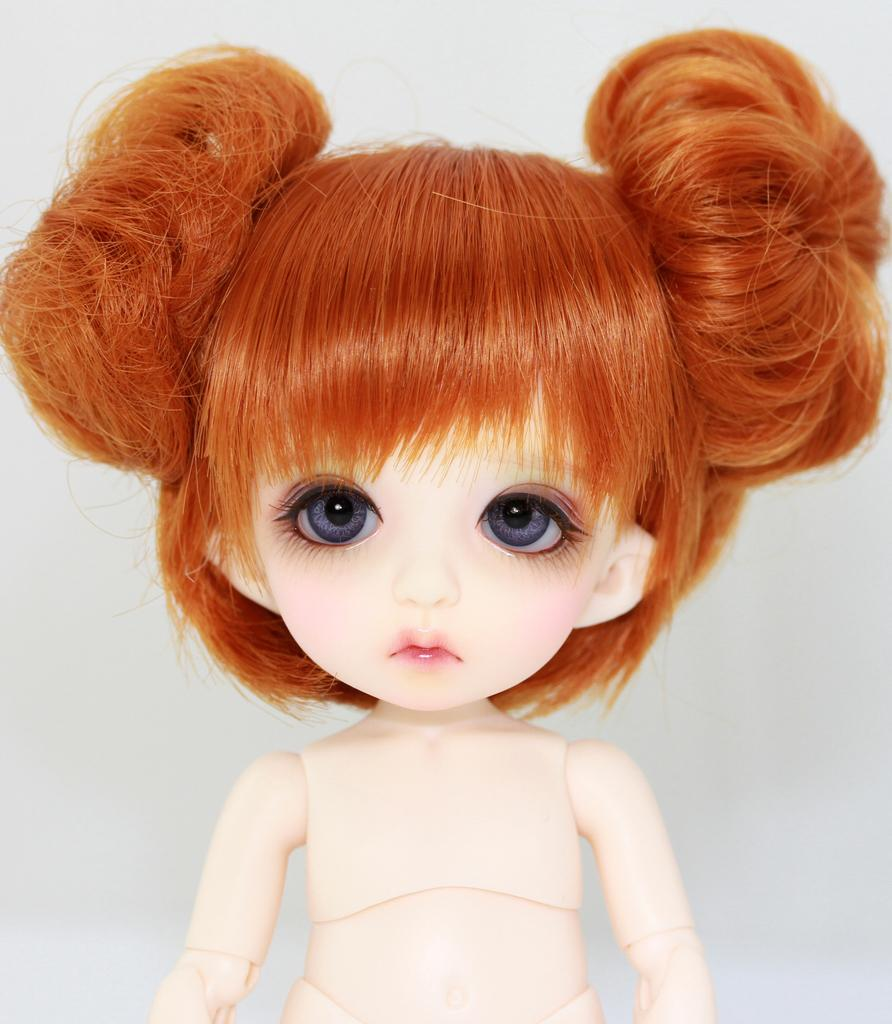What object in the image is designed for play or entertainment? There is a toy in the image. Can you see any waves crashing on the shore in the image? There is no reference to waves or a shore in the image, so it is not possible to answer that question. 